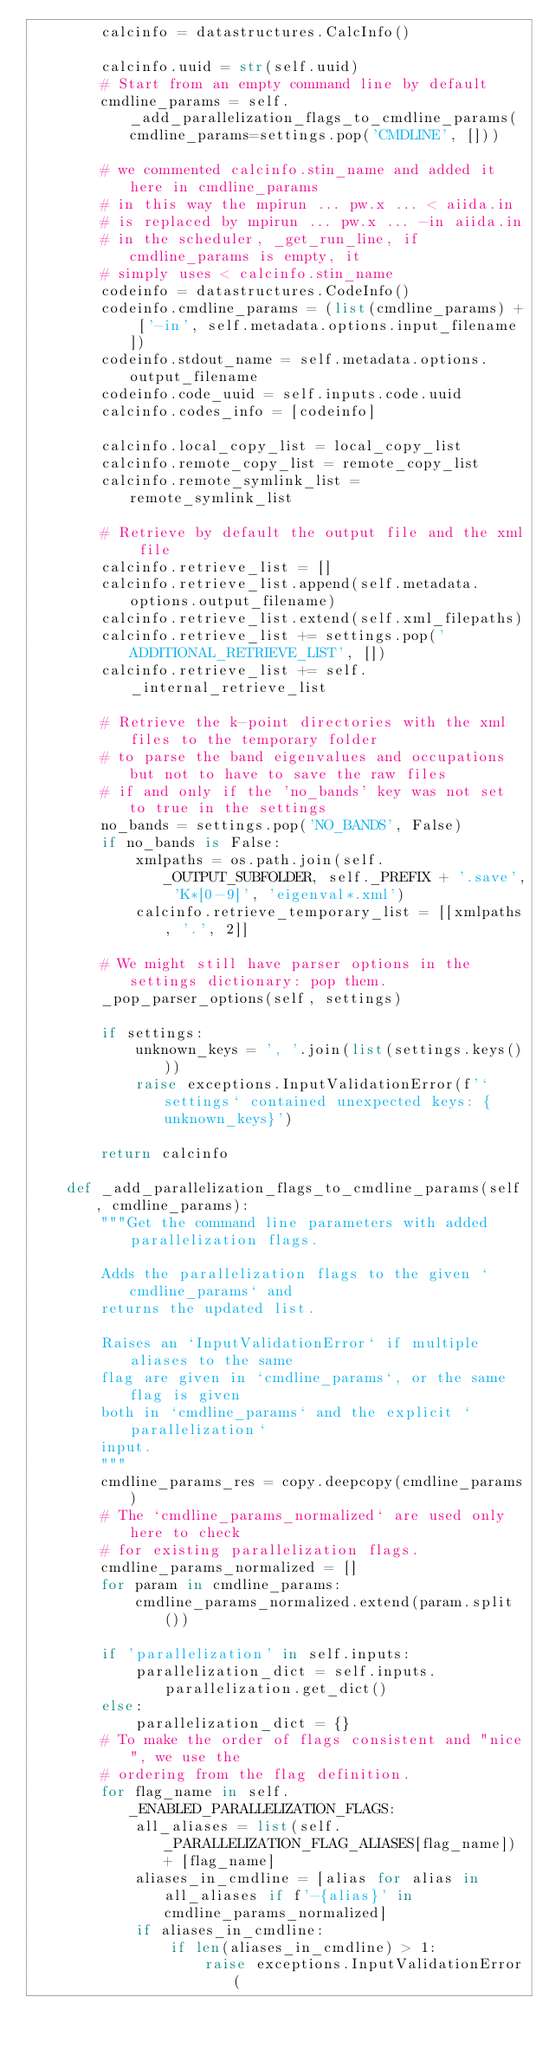Convert code to text. <code><loc_0><loc_0><loc_500><loc_500><_Python_>        calcinfo = datastructures.CalcInfo()

        calcinfo.uuid = str(self.uuid)
        # Start from an empty command line by default
        cmdline_params = self._add_parallelization_flags_to_cmdline_params(cmdline_params=settings.pop('CMDLINE', []))

        # we commented calcinfo.stin_name and added it here in cmdline_params
        # in this way the mpirun ... pw.x ... < aiida.in
        # is replaced by mpirun ... pw.x ... -in aiida.in
        # in the scheduler, _get_run_line, if cmdline_params is empty, it
        # simply uses < calcinfo.stin_name
        codeinfo = datastructures.CodeInfo()
        codeinfo.cmdline_params = (list(cmdline_params) + ['-in', self.metadata.options.input_filename])
        codeinfo.stdout_name = self.metadata.options.output_filename
        codeinfo.code_uuid = self.inputs.code.uuid
        calcinfo.codes_info = [codeinfo]

        calcinfo.local_copy_list = local_copy_list
        calcinfo.remote_copy_list = remote_copy_list
        calcinfo.remote_symlink_list = remote_symlink_list

        # Retrieve by default the output file and the xml file
        calcinfo.retrieve_list = []
        calcinfo.retrieve_list.append(self.metadata.options.output_filename)
        calcinfo.retrieve_list.extend(self.xml_filepaths)
        calcinfo.retrieve_list += settings.pop('ADDITIONAL_RETRIEVE_LIST', [])
        calcinfo.retrieve_list += self._internal_retrieve_list

        # Retrieve the k-point directories with the xml files to the temporary folder
        # to parse the band eigenvalues and occupations but not to have to save the raw files
        # if and only if the 'no_bands' key was not set to true in the settings
        no_bands = settings.pop('NO_BANDS', False)
        if no_bands is False:
            xmlpaths = os.path.join(self._OUTPUT_SUBFOLDER, self._PREFIX + '.save', 'K*[0-9]', 'eigenval*.xml')
            calcinfo.retrieve_temporary_list = [[xmlpaths, '.', 2]]

        # We might still have parser options in the settings dictionary: pop them.
        _pop_parser_options(self, settings)

        if settings:
            unknown_keys = ', '.join(list(settings.keys()))
            raise exceptions.InputValidationError(f'`settings` contained unexpected keys: {unknown_keys}')

        return calcinfo

    def _add_parallelization_flags_to_cmdline_params(self, cmdline_params):
        """Get the command line parameters with added parallelization flags.

        Adds the parallelization flags to the given `cmdline_params` and
        returns the updated list.

        Raises an `InputValidationError` if multiple aliases to the same
        flag are given in `cmdline_params`, or the same flag is given
        both in `cmdline_params` and the explicit `parallelization`
        input.
        """
        cmdline_params_res = copy.deepcopy(cmdline_params)
        # The `cmdline_params_normalized` are used only here to check
        # for existing parallelization flags.
        cmdline_params_normalized = []
        for param in cmdline_params:
            cmdline_params_normalized.extend(param.split())

        if 'parallelization' in self.inputs:
            parallelization_dict = self.inputs.parallelization.get_dict()
        else:
            parallelization_dict = {}
        # To make the order of flags consistent and "nice", we use the
        # ordering from the flag definition.
        for flag_name in self._ENABLED_PARALLELIZATION_FLAGS:
            all_aliases = list(self._PARALLELIZATION_FLAG_ALIASES[flag_name]) + [flag_name]
            aliases_in_cmdline = [alias for alias in all_aliases if f'-{alias}' in cmdline_params_normalized]
            if aliases_in_cmdline:
                if len(aliases_in_cmdline) > 1:
                    raise exceptions.InputValidationError(</code> 